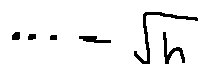Convert formula to latex. <formula><loc_0><loc_0><loc_500><loc_500>\cdots - \sqrt { h }</formula> 